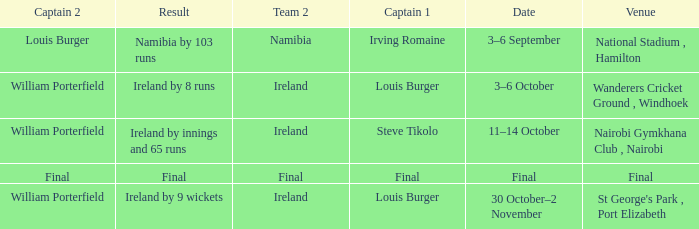Which Result has a Captain 1 of louis burger, and a Date of 30 october–2 november? Ireland by 9 wickets. 